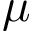<formula> <loc_0><loc_0><loc_500><loc_500>\mu</formula> 